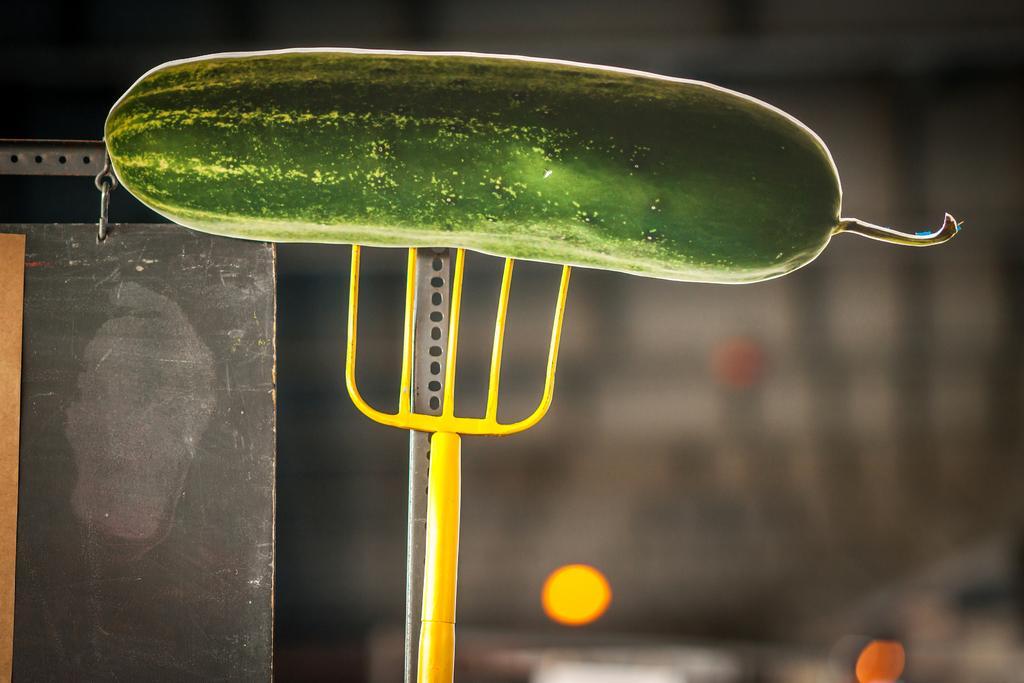Please provide a concise description of this image. In the foreground of this image, it seems like a cucumber to the fork like an object. On the left, there is a metal object and the background image is blurred. 